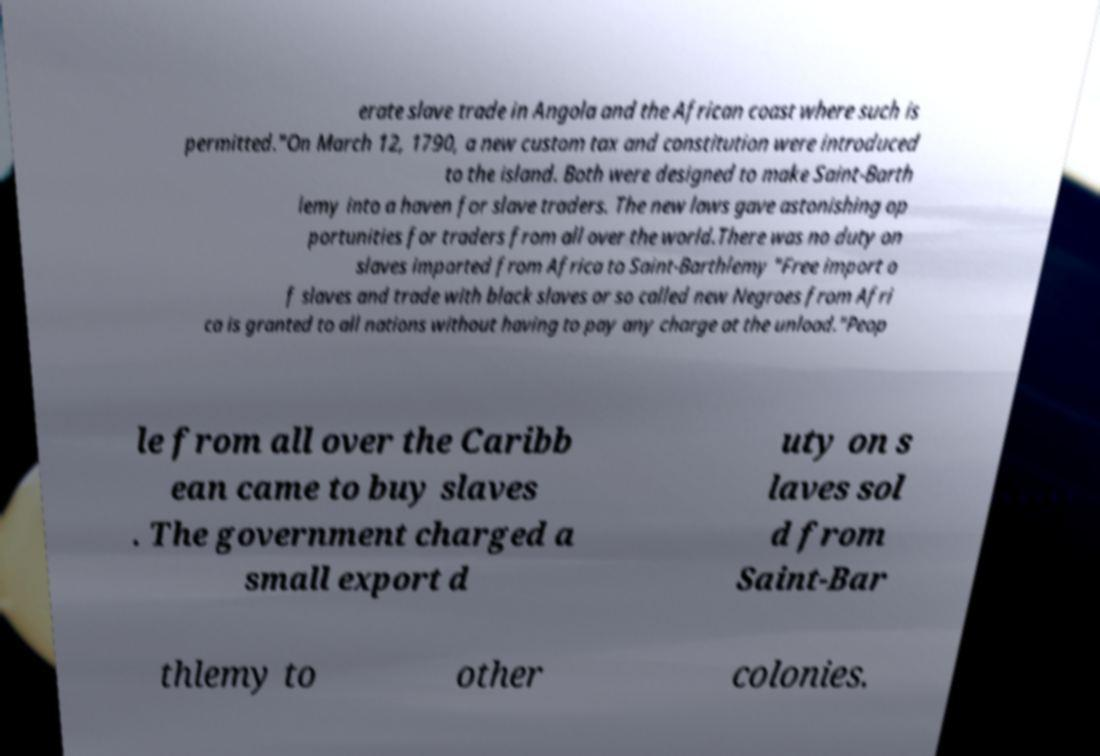There's text embedded in this image that I need extracted. Can you transcribe it verbatim? erate slave trade in Angola and the African coast where such is permitted."On March 12, 1790, a new custom tax and constitution were introduced to the island. Both were designed to make Saint-Barth lemy into a haven for slave traders. The new laws gave astonishing op portunities for traders from all over the world.There was no duty on slaves imported from Africa to Saint-Barthlemy "Free import o f slaves and trade with black slaves or so called new Negroes from Afri ca is granted to all nations without having to pay any charge at the unload."Peop le from all over the Caribb ean came to buy slaves . The government charged a small export d uty on s laves sol d from Saint-Bar thlemy to other colonies. 